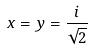Convert formula to latex. <formula><loc_0><loc_0><loc_500><loc_500>x = y = \frac { i } { \sqrt { 2 } }</formula> 